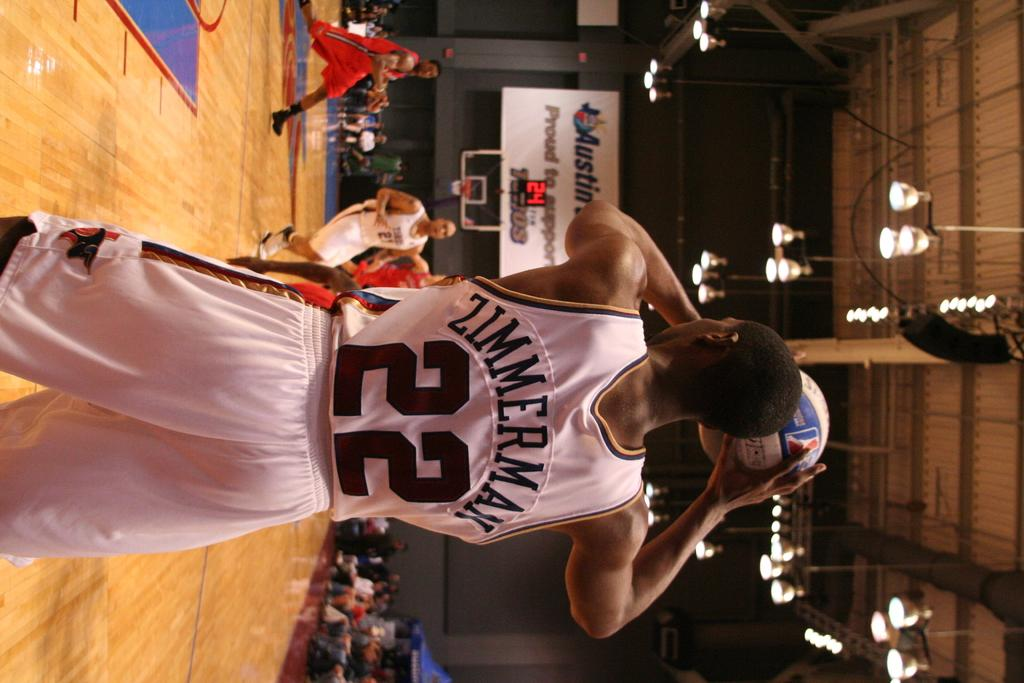<image>
Present a compact description of the photo's key features. Zimmerman is player number 22 on the basketball team. 